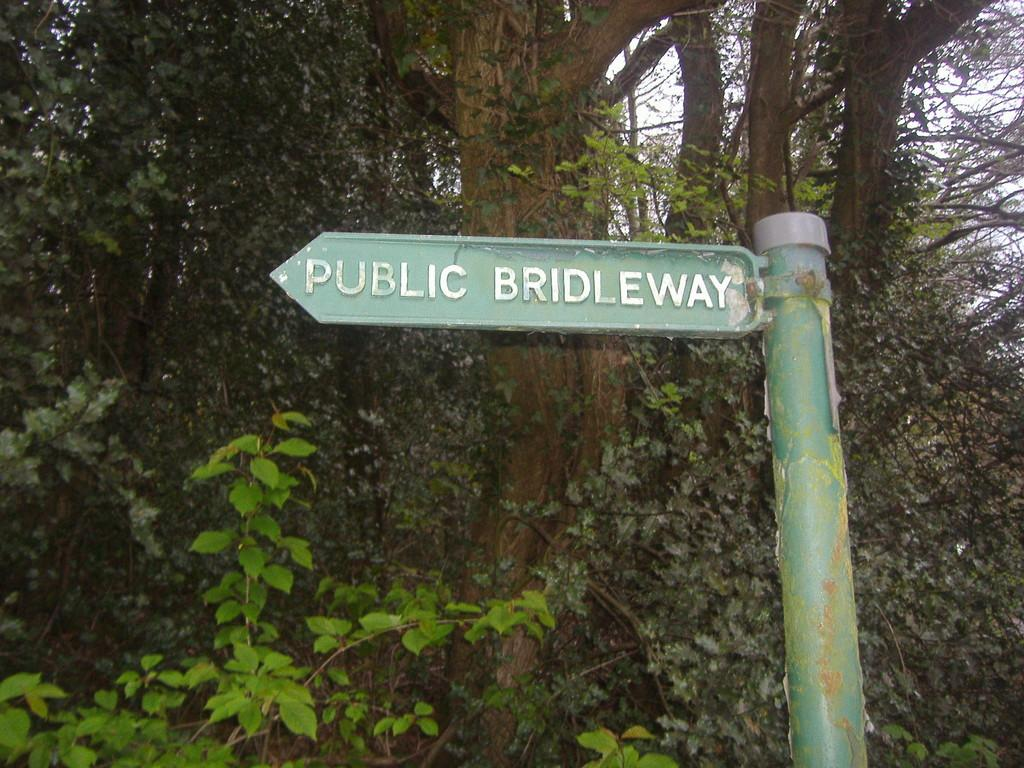What is the color of the sign board in the image? The sign board in the image is green. How is the sign board attached to the pole? The sign board is fixed to a pole. On which side of the image is the pole located? The pole is on the right side of the image. What can be found on the sign board? There is text on the sign board. What can be seen in the background of the image? There are trees in the background of the image. How many lizards are crawling on the sign board in the image? There are no lizards present on the sign board in the image. What type of paint is used on the sign board? The provided facts do not mention the type of paint used on the sign board. 